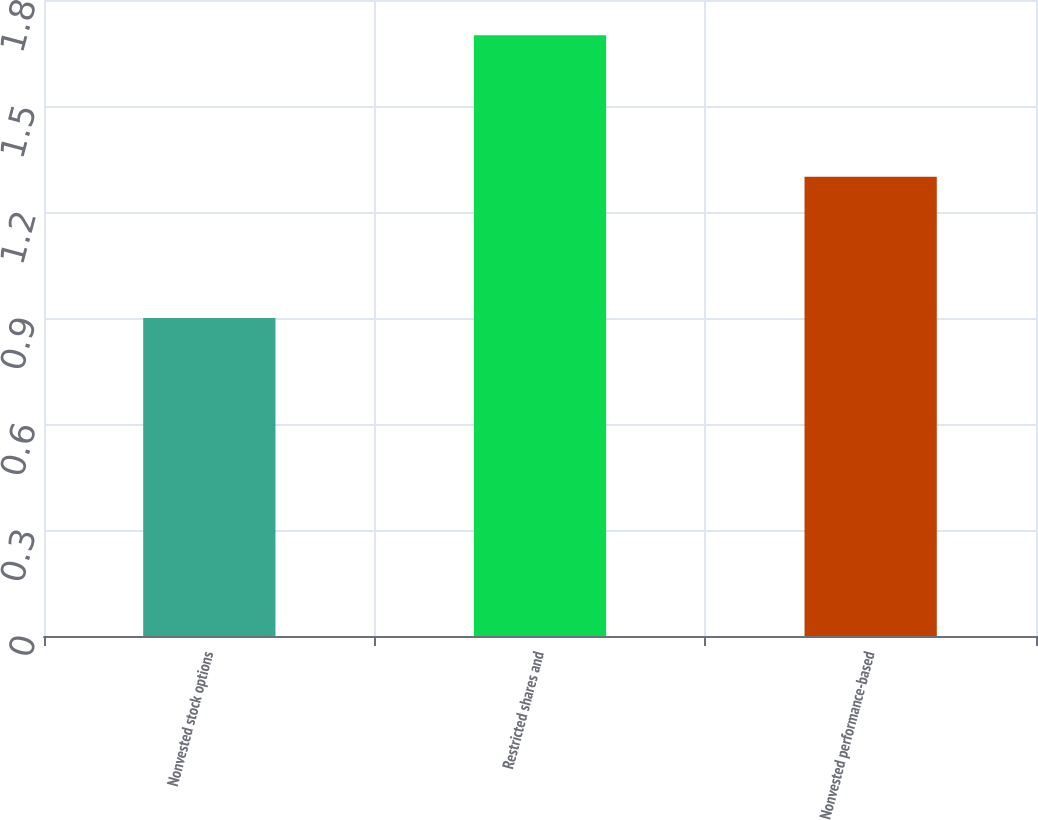Convert chart to OTSL. <chart><loc_0><loc_0><loc_500><loc_500><bar_chart><fcel>Nonvested stock options<fcel>Restricted shares and<fcel>Nonvested performance-based<nl><fcel>0.9<fcel>1.7<fcel>1.3<nl></chart> 